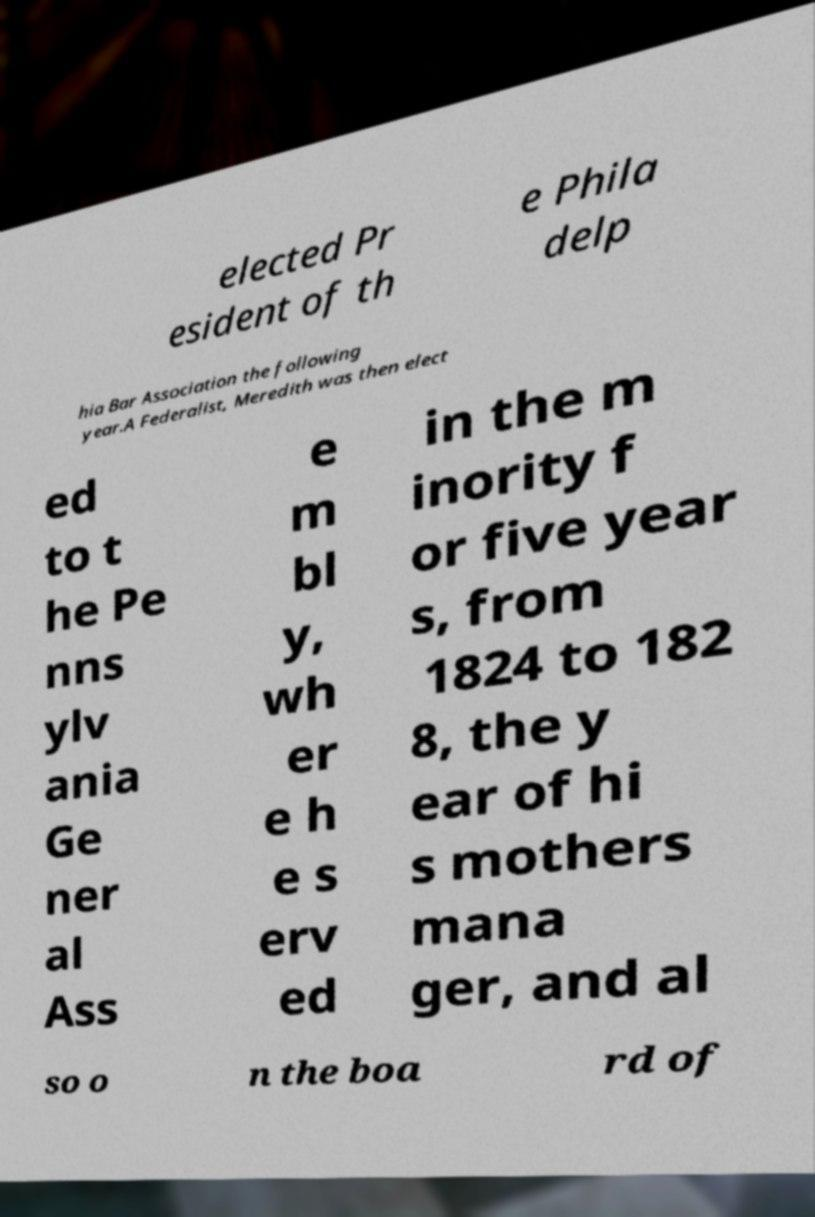Could you extract and type out the text from this image? elected Pr esident of th e Phila delp hia Bar Association the following year.A Federalist, Meredith was then elect ed to t he Pe nns ylv ania Ge ner al Ass e m bl y, wh er e h e s erv ed in the m inority f or five year s, from 1824 to 182 8, the y ear of hi s mothers mana ger, and al so o n the boa rd of 